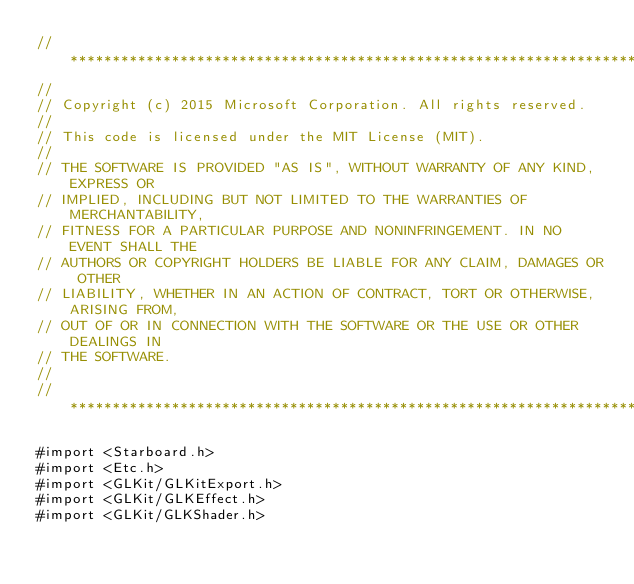Convert code to text. <code><loc_0><loc_0><loc_500><loc_500><_ObjectiveC_>//******************************************************************************
//
// Copyright (c) 2015 Microsoft Corporation. All rights reserved.
//
// This code is licensed under the MIT License (MIT).
//
// THE SOFTWARE IS PROVIDED "AS IS", WITHOUT WARRANTY OF ANY KIND, EXPRESS OR
// IMPLIED, INCLUDING BUT NOT LIMITED TO THE WARRANTIES OF MERCHANTABILITY,
// FITNESS FOR A PARTICULAR PURPOSE AND NONINFRINGEMENT. IN NO EVENT SHALL THE
// AUTHORS OR COPYRIGHT HOLDERS BE LIABLE FOR ANY CLAIM, DAMAGES OR OTHER
// LIABILITY, WHETHER IN AN ACTION OF CONTRACT, TORT OR OTHERWISE, ARISING FROM,
// OUT OF OR IN CONNECTION WITH THE SOFTWARE OR THE USE OR OTHER DEALINGS IN
// THE SOFTWARE.
//
//******************************************************************************

#import <Starboard.h>
#import <Etc.h>
#import <GLKit/GLKitExport.h>
#import <GLKit/GLKEffect.h>
#import <GLKit/GLKShader.h></code> 